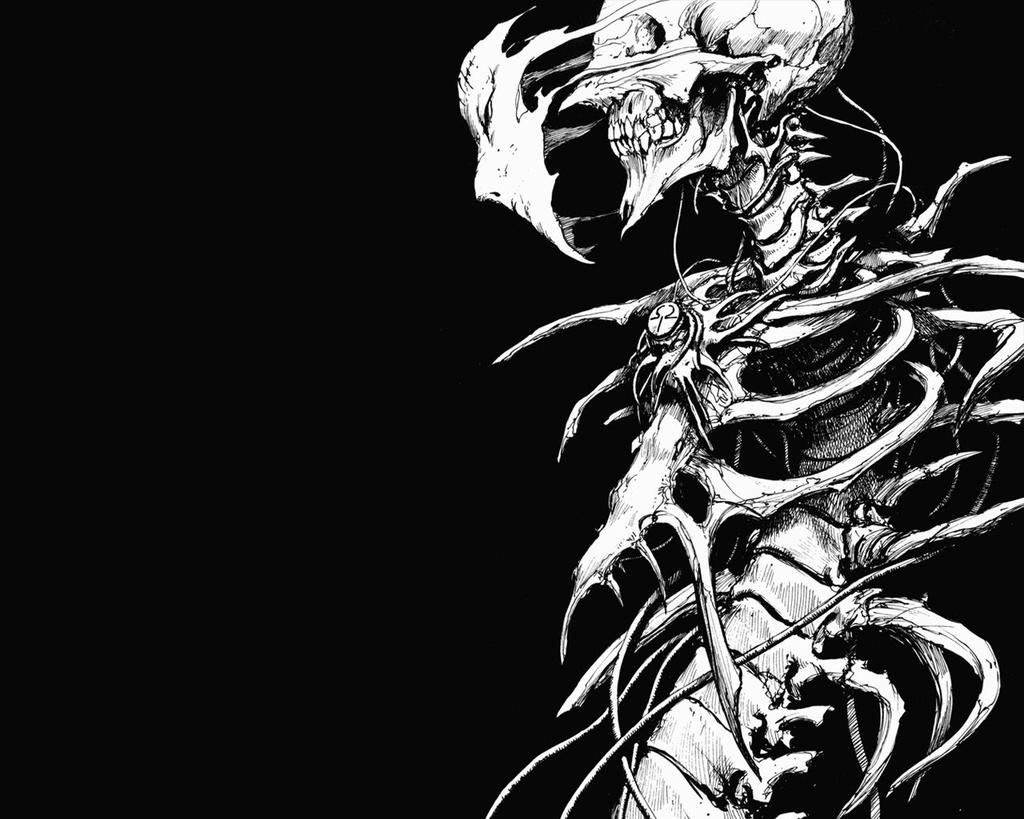What is the color scheme of the image? The image is black and white. What type of image is it? The image appears to be animated. What character or creature is present in the image? There is a demon in the image. What type of vessel can be seen sailing in the town in the image? There is no town or vessel present in the image; it is a black and white animated image featuring a demon. 